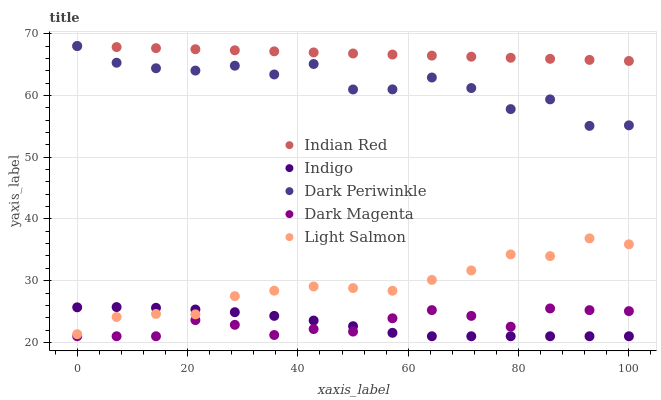Does Indigo have the minimum area under the curve?
Answer yes or no. Yes. Does Indian Red have the maximum area under the curve?
Answer yes or no. Yes. Does Dark Periwinkle have the minimum area under the curve?
Answer yes or no. No. Does Dark Periwinkle have the maximum area under the curve?
Answer yes or no. No. Is Indian Red the smoothest?
Answer yes or no. Yes. Is Dark Periwinkle the roughest?
Answer yes or no. Yes. Is Indigo the smoothest?
Answer yes or no. No. Is Indigo the roughest?
Answer yes or no. No. Does Indigo have the lowest value?
Answer yes or no. Yes. Does Dark Periwinkle have the lowest value?
Answer yes or no. No. Does Indian Red have the highest value?
Answer yes or no. Yes. Does Indigo have the highest value?
Answer yes or no. No. Is Indigo less than Dark Periwinkle?
Answer yes or no. Yes. Is Light Salmon greater than Dark Magenta?
Answer yes or no. Yes. Does Dark Periwinkle intersect Indian Red?
Answer yes or no. Yes. Is Dark Periwinkle less than Indian Red?
Answer yes or no. No. Is Dark Periwinkle greater than Indian Red?
Answer yes or no. No. Does Indigo intersect Dark Periwinkle?
Answer yes or no. No. 